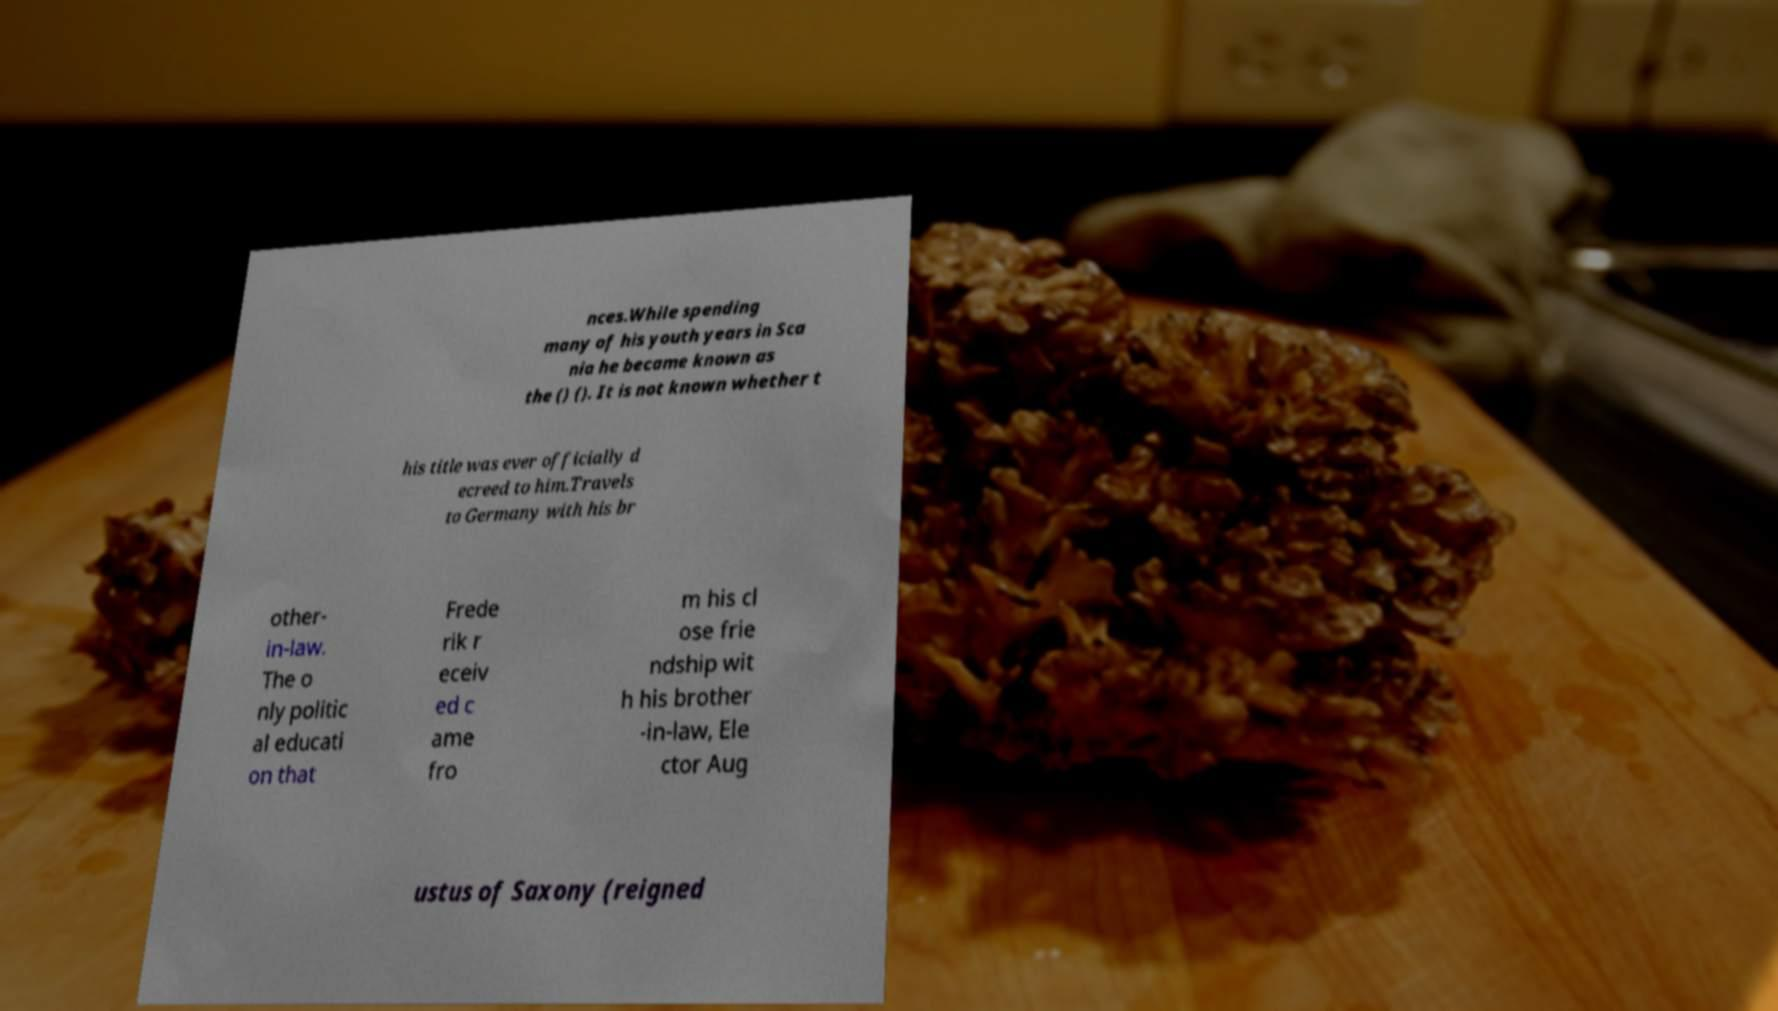For documentation purposes, I need the text within this image transcribed. Could you provide that? nces.While spending many of his youth years in Sca nia he became known as the () (). It is not known whether t his title was ever officially d ecreed to him.Travels to Germany with his br other- in-law. The o nly politic al educati on that Frede rik r eceiv ed c ame fro m his cl ose frie ndship wit h his brother -in-law, Ele ctor Aug ustus of Saxony (reigned 